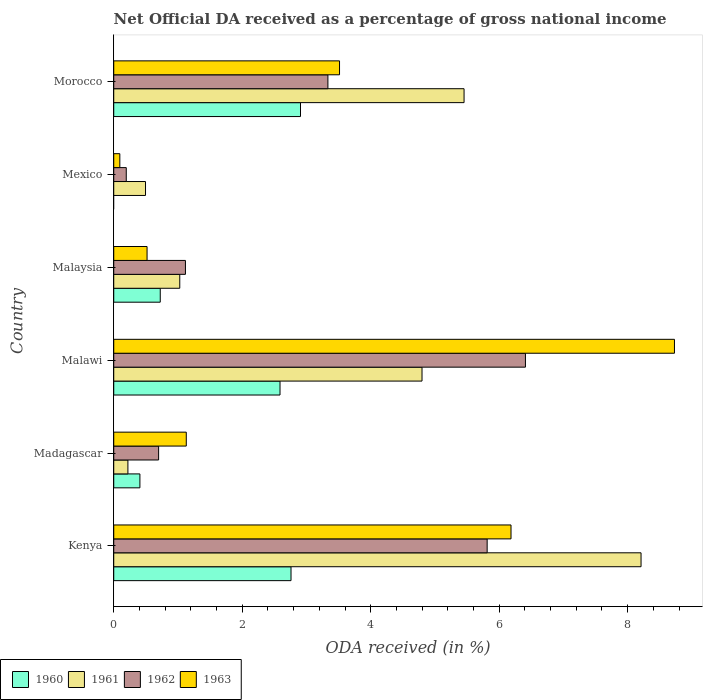How many groups of bars are there?
Keep it short and to the point. 6. Are the number of bars on each tick of the Y-axis equal?
Make the answer very short. No. How many bars are there on the 5th tick from the top?
Offer a very short reply. 4. How many bars are there on the 1st tick from the bottom?
Make the answer very short. 4. What is the label of the 6th group of bars from the top?
Offer a very short reply. Kenya. What is the net official DA received in 1961 in Morocco?
Your answer should be compact. 5.45. Across all countries, what is the maximum net official DA received in 1961?
Provide a succinct answer. 8.21. Across all countries, what is the minimum net official DA received in 1962?
Your answer should be very brief. 0.2. In which country was the net official DA received in 1963 maximum?
Provide a short and direct response. Malawi. What is the total net official DA received in 1963 in the graph?
Provide a short and direct response. 20.17. What is the difference between the net official DA received in 1962 in Malawi and that in Mexico?
Your answer should be very brief. 6.21. What is the difference between the net official DA received in 1961 in Morocco and the net official DA received in 1963 in Malaysia?
Give a very brief answer. 4.93. What is the average net official DA received in 1961 per country?
Your response must be concise. 3.37. What is the difference between the net official DA received in 1960 and net official DA received in 1963 in Malaysia?
Give a very brief answer. 0.21. What is the ratio of the net official DA received in 1963 in Madagascar to that in Mexico?
Your answer should be very brief. 11.92. Is the difference between the net official DA received in 1960 in Malawi and Malaysia greater than the difference between the net official DA received in 1963 in Malawi and Malaysia?
Make the answer very short. No. What is the difference between the highest and the second highest net official DA received in 1963?
Offer a very short reply. 2.54. What is the difference between the highest and the lowest net official DA received in 1962?
Offer a terse response. 6.21. Does the graph contain grids?
Provide a short and direct response. No. Where does the legend appear in the graph?
Your answer should be compact. Bottom left. What is the title of the graph?
Keep it short and to the point. Net Official DA received as a percentage of gross national income. Does "1966" appear as one of the legend labels in the graph?
Keep it short and to the point. No. What is the label or title of the X-axis?
Offer a very short reply. ODA received (in %). What is the ODA received (in %) in 1960 in Kenya?
Keep it short and to the point. 2.76. What is the ODA received (in %) of 1961 in Kenya?
Keep it short and to the point. 8.21. What is the ODA received (in %) in 1962 in Kenya?
Keep it short and to the point. 5.81. What is the ODA received (in %) in 1963 in Kenya?
Provide a succinct answer. 6.18. What is the ODA received (in %) of 1960 in Madagascar?
Your response must be concise. 0.41. What is the ODA received (in %) of 1961 in Madagascar?
Keep it short and to the point. 0.22. What is the ODA received (in %) of 1962 in Madagascar?
Your answer should be compact. 0.7. What is the ODA received (in %) of 1963 in Madagascar?
Offer a terse response. 1.13. What is the ODA received (in %) of 1960 in Malawi?
Make the answer very short. 2.59. What is the ODA received (in %) of 1961 in Malawi?
Provide a succinct answer. 4.8. What is the ODA received (in %) in 1962 in Malawi?
Keep it short and to the point. 6.41. What is the ODA received (in %) in 1963 in Malawi?
Keep it short and to the point. 8.73. What is the ODA received (in %) of 1960 in Malaysia?
Keep it short and to the point. 0.72. What is the ODA received (in %) of 1961 in Malaysia?
Your answer should be very brief. 1.03. What is the ODA received (in %) of 1962 in Malaysia?
Offer a terse response. 1.12. What is the ODA received (in %) of 1963 in Malaysia?
Offer a very short reply. 0.52. What is the ODA received (in %) in 1960 in Mexico?
Make the answer very short. 0. What is the ODA received (in %) of 1961 in Mexico?
Give a very brief answer. 0.49. What is the ODA received (in %) of 1962 in Mexico?
Your answer should be compact. 0.2. What is the ODA received (in %) in 1963 in Mexico?
Offer a very short reply. 0.09. What is the ODA received (in %) in 1960 in Morocco?
Your answer should be very brief. 2.91. What is the ODA received (in %) of 1961 in Morocco?
Your answer should be very brief. 5.45. What is the ODA received (in %) of 1962 in Morocco?
Your answer should be compact. 3.33. What is the ODA received (in %) in 1963 in Morocco?
Offer a very short reply. 3.51. Across all countries, what is the maximum ODA received (in %) in 1960?
Your answer should be very brief. 2.91. Across all countries, what is the maximum ODA received (in %) of 1961?
Offer a very short reply. 8.21. Across all countries, what is the maximum ODA received (in %) of 1962?
Offer a terse response. 6.41. Across all countries, what is the maximum ODA received (in %) of 1963?
Provide a succinct answer. 8.73. Across all countries, what is the minimum ODA received (in %) of 1961?
Provide a succinct answer. 0.22. Across all countries, what is the minimum ODA received (in %) of 1962?
Provide a succinct answer. 0.2. Across all countries, what is the minimum ODA received (in %) in 1963?
Ensure brevity in your answer.  0.09. What is the total ODA received (in %) in 1960 in the graph?
Ensure brevity in your answer.  9.39. What is the total ODA received (in %) in 1961 in the graph?
Ensure brevity in your answer.  20.2. What is the total ODA received (in %) of 1962 in the graph?
Your answer should be very brief. 17.56. What is the total ODA received (in %) of 1963 in the graph?
Your response must be concise. 20.17. What is the difference between the ODA received (in %) of 1960 in Kenya and that in Madagascar?
Make the answer very short. 2.35. What is the difference between the ODA received (in %) in 1961 in Kenya and that in Madagascar?
Provide a short and direct response. 7.99. What is the difference between the ODA received (in %) of 1962 in Kenya and that in Madagascar?
Keep it short and to the point. 5.11. What is the difference between the ODA received (in %) of 1963 in Kenya and that in Madagascar?
Keep it short and to the point. 5.06. What is the difference between the ODA received (in %) in 1960 in Kenya and that in Malawi?
Provide a succinct answer. 0.17. What is the difference between the ODA received (in %) in 1961 in Kenya and that in Malawi?
Give a very brief answer. 3.41. What is the difference between the ODA received (in %) of 1962 in Kenya and that in Malawi?
Provide a succinct answer. -0.6. What is the difference between the ODA received (in %) in 1963 in Kenya and that in Malawi?
Give a very brief answer. -2.54. What is the difference between the ODA received (in %) in 1960 in Kenya and that in Malaysia?
Offer a very short reply. 2.04. What is the difference between the ODA received (in %) in 1961 in Kenya and that in Malaysia?
Provide a short and direct response. 7.18. What is the difference between the ODA received (in %) in 1962 in Kenya and that in Malaysia?
Provide a succinct answer. 4.7. What is the difference between the ODA received (in %) of 1963 in Kenya and that in Malaysia?
Your answer should be compact. 5.67. What is the difference between the ODA received (in %) in 1961 in Kenya and that in Mexico?
Provide a succinct answer. 7.71. What is the difference between the ODA received (in %) in 1962 in Kenya and that in Mexico?
Your answer should be compact. 5.62. What is the difference between the ODA received (in %) in 1963 in Kenya and that in Mexico?
Your answer should be compact. 6.09. What is the difference between the ODA received (in %) of 1960 in Kenya and that in Morocco?
Your answer should be very brief. -0.15. What is the difference between the ODA received (in %) in 1961 in Kenya and that in Morocco?
Provide a short and direct response. 2.76. What is the difference between the ODA received (in %) of 1962 in Kenya and that in Morocco?
Offer a terse response. 2.48. What is the difference between the ODA received (in %) of 1963 in Kenya and that in Morocco?
Offer a very short reply. 2.67. What is the difference between the ODA received (in %) in 1960 in Madagascar and that in Malawi?
Ensure brevity in your answer.  -2.18. What is the difference between the ODA received (in %) of 1961 in Madagascar and that in Malawi?
Your answer should be very brief. -4.58. What is the difference between the ODA received (in %) of 1962 in Madagascar and that in Malawi?
Provide a succinct answer. -5.71. What is the difference between the ODA received (in %) of 1963 in Madagascar and that in Malawi?
Make the answer very short. -7.6. What is the difference between the ODA received (in %) of 1960 in Madagascar and that in Malaysia?
Offer a terse response. -0.32. What is the difference between the ODA received (in %) in 1961 in Madagascar and that in Malaysia?
Offer a very short reply. -0.81. What is the difference between the ODA received (in %) of 1962 in Madagascar and that in Malaysia?
Ensure brevity in your answer.  -0.42. What is the difference between the ODA received (in %) of 1963 in Madagascar and that in Malaysia?
Keep it short and to the point. 0.61. What is the difference between the ODA received (in %) of 1961 in Madagascar and that in Mexico?
Give a very brief answer. -0.27. What is the difference between the ODA received (in %) in 1962 in Madagascar and that in Mexico?
Make the answer very short. 0.5. What is the difference between the ODA received (in %) of 1963 in Madagascar and that in Mexico?
Your response must be concise. 1.03. What is the difference between the ODA received (in %) of 1960 in Madagascar and that in Morocco?
Provide a short and direct response. -2.5. What is the difference between the ODA received (in %) of 1961 in Madagascar and that in Morocco?
Your answer should be compact. -5.23. What is the difference between the ODA received (in %) of 1962 in Madagascar and that in Morocco?
Provide a short and direct response. -2.64. What is the difference between the ODA received (in %) of 1963 in Madagascar and that in Morocco?
Give a very brief answer. -2.39. What is the difference between the ODA received (in %) of 1960 in Malawi and that in Malaysia?
Your response must be concise. 1.86. What is the difference between the ODA received (in %) in 1961 in Malawi and that in Malaysia?
Your answer should be compact. 3.77. What is the difference between the ODA received (in %) in 1962 in Malawi and that in Malaysia?
Make the answer very short. 5.29. What is the difference between the ODA received (in %) of 1963 in Malawi and that in Malaysia?
Your response must be concise. 8.21. What is the difference between the ODA received (in %) in 1961 in Malawi and that in Mexico?
Make the answer very short. 4.3. What is the difference between the ODA received (in %) of 1962 in Malawi and that in Mexico?
Keep it short and to the point. 6.21. What is the difference between the ODA received (in %) of 1963 in Malawi and that in Mexico?
Provide a short and direct response. 8.63. What is the difference between the ODA received (in %) in 1960 in Malawi and that in Morocco?
Offer a very short reply. -0.32. What is the difference between the ODA received (in %) in 1961 in Malawi and that in Morocco?
Your response must be concise. -0.65. What is the difference between the ODA received (in %) in 1962 in Malawi and that in Morocco?
Provide a succinct answer. 3.08. What is the difference between the ODA received (in %) in 1963 in Malawi and that in Morocco?
Ensure brevity in your answer.  5.21. What is the difference between the ODA received (in %) of 1961 in Malaysia and that in Mexico?
Offer a terse response. 0.53. What is the difference between the ODA received (in %) of 1962 in Malaysia and that in Mexico?
Ensure brevity in your answer.  0.92. What is the difference between the ODA received (in %) of 1963 in Malaysia and that in Mexico?
Provide a succinct answer. 0.42. What is the difference between the ODA received (in %) in 1960 in Malaysia and that in Morocco?
Provide a succinct answer. -2.18. What is the difference between the ODA received (in %) of 1961 in Malaysia and that in Morocco?
Offer a terse response. -4.43. What is the difference between the ODA received (in %) in 1962 in Malaysia and that in Morocco?
Offer a terse response. -2.22. What is the difference between the ODA received (in %) of 1963 in Malaysia and that in Morocco?
Ensure brevity in your answer.  -3. What is the difference between the ODA received (in %) in 1961 in Mexico and that in Morocco?
Keep it short and to the point. -4.96. What is the difference between the ODA received (in %) of 1962 in Mexico and that in Morocco?
Make the answer very short. -3.14. What is the difference between the ODA received (in %) in 1963 in Mexico and that in Morocco?
Keep it short and to the point. -3.42. What is the difference between the ODA received (in %) of 1960 in Kenya and the ODA received (in %) of 1961 in Madagascar?
Provide a short and direct response. 2.54. What is the difference between the ODA received (in %) in 1960 in Kenya and the ODA received (in %) in 1962 in Madagascar?
Make the answer very short. 2.06. What is the difference between the ODA received (in %) of 1960 in Kenya and the ODA received (in %) of 1963 in Madagascar?
Ensure brevity in your answer.  1.63. What is the difference between the ODA received (in %) of 1961 in Kenya and the ODA received (in %) of 1962 in Madagascar?
Ensure brevity in your answer.  7.51. What is the difference between the ODA received (in %) in 1961 in Kenya and the ODA received (in %) in 1963 in Madagascar?
Your response must be concise. 7.08. What is the difference between the ODA received (in %) of 1962 in Kenya and the ODA received (in %) of 1963 in Madagascar?
Offer a very short reply. 4.68. What is the difference between the ODA received (in %) of 1960 in Kenya and the ODA received (in %) of 1961 in Malawi?
Provide a succinct answer. -2.04. What is the difference between the ODA received (in %) of 1960 in Kenya and the ODA received (in %) of 1962 in Malawi?
Ensure brevity in your answer.  -3.65. What is the difference between the ODA received (in %) of 1960 in Kenya and the ODA received (in %) of 1963 in Malawi?
Offer a terse response. -5.97. What is the difference between the ODA received (in %) of 1961 in Kenya and the ODA received (in %) of 1962 in Malawi?
Keep it short and to the point. 1.8. What is the difference between the ODA received (in %) of 1961 in Kenya and the ODA received (in %) of 1963 in Malawi?
Provide a succinct answer. -0.52. What is the difference between the ODA received (in %) in 1962 in Kenya and the ODA received (in %) in 1963 in Malawi?
Make the answer very short. -2.92. What is the difference between the ODA received (in %) in 1960 in Kenya and the ODA received (in %) in 1961 in Malaysia?
Ensure brevity in your answer.  1.73. What is the difference between the ODA received (in %) of 1960 in Kenya and the ODA received (in %) of 1962 in Malaysia?
Ensure brevity in your answer.  1.64. What is the difference between the ODA received (in %) in 1960 in Kenya and the ODA received (in %) in 1963 in Malaysia?
Give a very brief answer. 2.24. What is the difference between the ODA received (in %) of 1961 in Kenya and the ODA received (in %) of 1962 in Malaysia?
Provide a short and direct response. 7.09. What is the difference between the ODA received (in %) in 1961 in Kenya and the ODA received (in %) in 1963 in Malaysia?
Keep it short and to the point. 7.69. What is the difference between the ODA received (in %) of 1962 in Kenya and the ODA received (in %) of 1963 in Malaysia?
Your response must be concise. 5.29. What is the difference between the ODA received (in %) of 1960 in Kenya and the ODA received (in %) of 1961 in Mexico?
Your answer should be very brief. 2.26. What is the difference between the ODA received (in %) in 1960 in Kenya and the ODA received (in %) in 1962 in Mexico?
Ensure brevity in your answer.  2.56. What is the difference between the ODA received (in %) of 1960 in Kenya and the ODA received (in %) of 1963 in Mexico?
Provide a succinct answer. 2.66. What is the difference between the ODA received (in %) of 1961 in Kenya and the ODA received (in %) of 1962 in Mexico?
Your answer should be very brief. 8.01. What is the difference between the ODA received (in %) in 1961 in Kenya and the ODA received (in %) in 1963 in Mexico?
Give a very brief answer. 8.11. What is the difference between the ODA received (in %) in 1962 in Kenya and the ODA received (in %) in 1963 in Mexico?
Your answer should be compact. 5.72. What is the difference between the ODA received (in %) of 1960 in Kenya and the ODA received (in %) of 1961 in Morocco?
Your answer should be compact. -2.69. What is the difference between the ODA received (in %) of 1960 in Kenya and the ODA received (in %) of 1962 in Morocco?
Your answer should be compact. -0.57. What is the difference between the ODA received (in %) in 1960 in Kenya and the ODA received (in %) in 1963 in Morocco?
Make the answer very short. -0.76. What is the difference between the ODA received (in %) in 1961 in Kenya and the ODA received (in %) in 1962 in Morocco?
Offer a terse response. 4.87. What is the difference between the ODA received (in %) in 1961 in Kenya and the ODA received (in %) in 1963 in Morocco?
Ensure brevity in your answer.  4.69. What is the difference between the ODA received (in %) of 1962 in Kenya and the ODA received (in %) of 1963 in Morocco?
Offer a terse response. 2.3. What is the difference between the ODA received (in %) in 1960 in Madagascar and the ODA received (in %) in 1961 in Malawi?
Make the answer very short. -4.39. What is the difference between the ODA received (in %) of 1960 in Madagascar and the ODA received (in %) of 1962 in Malawi?
Keep it short and to the point. -6. What is the difference between the ODA received (in %) of 1960 in Madagascar and the ODA received (in %) of 1963 in Malawi?
Make the answer very short. -8.32. What is the difference between the ODA received (in %) of 1961 in Madagascar and the ODA received (in %) of 1962 in Malawi?
Offer a very short reply. -6.19. What is the difference between the ODA received (in %) of 1961 in Madagascar and the ODA received (in %) of 1963 in Malawi?
Ensure brevity in your answer.  -8.51. What is the difference between the ODA received (in %) in 1962 in Madagascar and the ODA received (in %) in 1963 in Malawi?
Make the answer very short. -8.03. What is the difference between the ODA received (in %) in 1960 in Madagascar and the ODA received (in %) in 1961 in Malaysia?
Offer a terse response. -0.62. What is the difference between the ODA received (in %) of 1960 in Madagascar and the ODA received (in %) of 1962 in Malaysia?
Provide a short and direct response. -0.71. What is the difference between the ODA received (in %) of 1960 in Madagascar and the ODA received (in %) of 1963 in Malaysia?
Your answer should be compact. -0.11. What is the difference between the ODA received (in %) in 1961 in Madagascar and the ODA received (in %) in 1962 in Malaysia?
Provide a short and direct response. -0.9. What is the difference between the ODA received (in %) in 1961 in Madagascar and the ODA received (in %) in 1963 in Malaysia?
Offer a very short reply. -0.3. What is the difference between the ODA received (in %) in 1962 in Madagascar and the ODA received (in %) in 1963 in Malaysia?
Your answer should be very brief. 0.18. What is the difference between the ODA received (in %) in 1960 in Madagascar and the ODA received (in %) in 1961 in Mexico?
Your response must be concise. -0.09. What is the difference between the ODA received (in %) of 1960 in Madagascar and the ODA received (in %) of 1962 in Mexico?
Give a very brief answer. 0.21. What is the difference between the ODA received (in %) of 1960 in Madagascar and the ODA received (in %) of 1963 in Mexico?
Offer a very short reply. 0.31. What is the difference between the ODA received (in %) in 1961 in Madagascar and the ODA received (in %) in 1962 in Mexico?
Offer a terse response. 0.03. What is the difference between the ODA received (in %) of 1961 in Madagascar and the ODA received (in %) of 1963 in Mexico?
Ensure brevity in your answer.  0.13. What is the difference between the ODA received (in %) in 1962 in Madagascar and the ODA received (in %) in 1963 in Mexico?
Offer a terse response. 0.6. What is the difference between the ODA received (in %) in 1960 in Madagascar and the ODA received (in %) in 1961 in Morocco?
Make the answer very short. -5.05. What is the difference between the ODA received (in %) in 1960 in Madagascar and the ODA received (in %) in 1962 in Morocco?
Your answer should be very brief. -2.93. What is the difference between the ODA received (in %) in 1960 in Madagascar and the ODA received (in %) in 1963 in Morocco?
Make the answer very short. -3.11. What is the difference between the ODA received (in %) of 1961 in Madagascar and the ODA received (in %) of 1962 in Morocco?
Give a very brief answer. -3.11. What is the difference between the ODA received (in %) in 1961 in Madagascar and the ODA received (in %) in 1963 in Morocco?
Your response must be concise. -3.29. What is the difference between the ODA received (in %) in 1962 in Madagascar and the ODA received (in %) in 1963 in Morocco?
Give a very brief answer. -2.82. What is the difference between the ODA received (in %) in 1960 in Malawi and the ODA received (in %) in 1961 in Malaysia?
Your response must be concise. 1.56. What is the difference between the ODA received (in %) in 1960 in Malawi and the ODA received (in %) in 1962 in Malaysia?
Offer a terse response. 1.47. What is the difference between the ODA received (in %) in 1960 in Malawi and the ODA received (in %) in 1963 in Malaysia?
Your answer should be very brief. 2.07. What is the difference between the ODA received (in %) in 1961 in Malawi and the ODA received (in %) in 1962 in Malaysia?
Your answer should be compact. 3.68. What is the difference between the ODA received (in %) in 1961 in Malawi and the ODA received (in %) in 1963 in Malaysia?
Provide a short and direct response. 4.28. What is the difference between the ODA received (in %) of 1962 in Malawi and the ODA received (in %) of 1963 in Malaysia?
Keep it short and to the point. 5.89. What is the difference between the ODA received (in %) of 1960 in Malawi and the ODA received (in %) of 1961 in Mexico?
Provide a succinct answer. 2.09. What is the difference between the ODA received (in %) in 1960 in Malawi and the ODA received (in %) in 1962 in Mexico?
Provide a succinct answer. 2.39. What is the difference between the ODA received (in %) of 1960 in Malawi and the ODA received (in %) of 1963 in Mexico?
Offer a terse response. 2.49. What is the difference between the ODA received (in %) of 1961 in Malawi and the ODA received (in %) of 1962 in Mexico?
Provide a succinct answer. 4.6. What is the difference between the ODA received (in %) in 1961 in Malawi and the ODA received (in %) in 1963 in Mexico?
Make the answer very short. 4.7. What is the difference between the ODA received (in %) of 1962 in Malawi and the ODA received (in %) of 1963 in Mexico?
Give a very brief answer. 6.31. What is the difference between the ODA received (in %) of 1960 in Malawi and the ODA received (in %) of 1961 in Morocco?
Your response must be concise. -2.87. What is the difference between the ODA received (in %) of 1960 in Malawi and the ODA received (in %) of 1962 in Morocco?
Offer a very short reply. -0.75. What is the difference between the ODA received (in %) in 1960 in Malawi and the ODA received (in %) in 1963 in Morocco?
Your answer should be very brief. -0.93. What is the difference between the ODA received (in %) of 1961 in Malawi and the ODA received (in %) of 1962 in Morocco?
Offer a terse response. 1.47. What is the difference between the ODA received (in %) of 1961 in Malawi and the ODA received (in %) of 1963 in Morocco?
Your answer should be compact. 1.28. What is the difference between the ODA received (in %) of 1962 in Malawi and the ODA received (in %) of 1963 in Morocco?
Make the answer very short. 2.89. What is the difference between the ODA received (in %) of 1960 in Malaysia and the ODA received (in %) of 1961 in Mexico?
Offer a very short reply. 0.23. What is the difference between the ODA received (in %) of 1960 in Malaysia and the ODA received (in %) of 1962 in Mexico?
Give a very brief answer. 0.53. What is the difference between the ODA received (in %) of 1960 in Malaysia and the ODA received (in %) of 1963 in Mexico?
Keep it short and to the point. 0.63. What is the difference between the ODA received (in %) of 1961 in Malaysia and the ODA received (in %) of 1962 in Mexico?
Provide a succinct answer. 0.83. What is the difference between the ODA received (in %) of 1961 in Malaysia and the ODA received (in %) of 1963 in Mexico?
Provide a succinct answer. 0.93. What is the difference between the ODA received (in %) in 1962 in Malaysia and the ODA received (in %) in 1963 in Mexico?
Provide a succinct answer. 1.02. What is the difference between the ODA received (in %) in 1960 in Malaysia and the ODA received (in %) in 1961 in Morocco?
Give a very brief answer. -4.73. What is the difference between the ODA received (in %) of 1960 in Malaysia and the ODA received (in %) of 1962 in Morocco?
Your answer should be compact. -2.61. What is the difference between the ODA received (in %) in 1960 in Malaysia and the ODA received (in %) in 1963 in Morocco?
Offer a very short reply. -2.79. What is the difference between the ODA received (in %) of 1961 in Malaysia and the ODA received (in %) of 1962 in Morocco?
Give a very brief answer. -2.31. What is the difference between the ODA received (in %) in 1961 in Malaysia and the ODA received (in %) in 1963 in Morocco?
Offer a very short reply. -2.49. What is the difference between the ODA received (in %) of 1962 in Malaysia and the ODA received (in %) of 1963 in Morocco?
Offer a very short reply. -2.4. What is the difference between the ODA received (in %) of 1961 in Mexico and the ODA received (in %) of 1962 in Morocco?
Offer a terse response. -2.84. What is the difference between the ODA received (in %) of 1961 in Mexico and the ODA received (in %) of 1963 in Morocco?
Make the answer very short. -3.02. What is the difference between the ODA received (in %) of 1962 in Mexico and the ODA received (in %) of 1963 in Morocco?
Offer a very short reply. -3.32. What is the average ODA received (in %) in 1960 per country?
Keep it short and to the point. 1.56. What is the average ODA received (in %) in 1961 per country?
Your response must be concise. 3.37. What is the average ODA received (in %) of 1962 per country?
Provide a short and direct response. 2.93. What is the average ODA received (in %) of 1963 per country?
Your answer should be compact. 3.36. What is the difference between the ODA received (in %) in 1960 and ODA received (in %) in 1961 in Kenya?
Offer a very short reply. -5.45. What is the difference between the ODA received (in %) in 1960 and ODA received (in %) in 1962 in Kenya?
Give a very brief answer. -3.05. What is the difference between the ODA received (in %) in 1960 and ODA received (in %) in 1963 in Kenya?
Offer a terse response. -3.42. What is the difference between the ODA received (in %) of 1961 and ODA received (in %) of 1962 in Kenya?
Give a very brief answer. 2.4. What is the difference between the ODA received (in %) of 1961 and ODA received (in %) of 1963 in Kenya?
Give a very brief answer. 2.02. What is the difference between the ODA received (in %) in 1962 and ODA received (in %) in 1963 in Kenya?
Keep it short and to the point. -0.37. What is the difference between the ODA received (in %) in 1960 and ODA received (in %) in 1961 in Madagascar?
Offer a very short reply. 0.19. What is the difference between the ODA received (in %) in 1960 and ODA received (in %) in 1962 in Madagascar?
Your answer should be compact. -0.29. What is the difference between the ODA received (in %) in 1960 and ODA received (in %) in 1963 in Madagascar?
Your answer should be compact. -0.72. What is the difference between the ODA received (in %) of 1961 and ODA received (in %) of 1962 in Madagascar?
Your answer should be compact. -0.48. What is the difference between the ODA received (in %) in 1961 and ODA received (in %) in 1963 in Madagascar?
Make the answer very short. -0.91. What is the difference between the ODA received (in %) of 1962 and ODA received (in %) of 1963 in Madagascar?
Your answer should be very brief. -0.43. What is the difference between the ODA received (in %) in 1960 and ODA received (in %) in 1961 in Malawi?
Your answer should be very brief. -2.21. What is the difference between the ODA received (in %) in 1960 and ODA received (in %) in 1962 in Malawi?
Your response must be concise. -3.82. What is the difference between the ODA received (in %) in 1960 and ODA received (in %) in 1963 in Malawi?
Ensure brevity in your answer.  -6.14. What is the difference between the ODA received (in %) in 1961 and ODA received (in %) in 1962 in Malawi?
Your answer should be very brief. -1.61. What is the difference between the ODA received (in %) of 1961 and ODA received (in %) of 1963 in Malawi?
Provide a succinct answer. -3.93. What is the difference between the ODA received (in %) of 1962 and ODA received (in %) of 1963 in Malawi?
Give a very brief answer. -2.32. What is the difference between the ODA received (in %) of 1960 and ODA received (in %) of 1961 in Malaysia?
Make the answer very short. -0.3. What is the difference between the ODA received (in %) in 1960 and ODA received (in %) in 1962 in Malaysia?
Your answer should be very brief. -0.39. What is the difference between the ODA received (in %) in 1960 and ODA received (in %) in 1963 in Malaysia?
Your answer should be compact. 0.21. What is the difference between the ODA received (in %) of 1961 and ODA received (in %) of 1962 in Malaysia?
Provide a short and direct response. -0.09. What is the difference between the ODA received (in %) of 1961 and ODA received (in %) of 1963 in Malaysia?
Offer a terse response. 0.51. What is the difference between the ODA received (in %) in 1962 and ODA received (in %) in 1963 in Malaysia?
Ensure brevity in your answer.  0.6. What is the difference between the ODA received (in %) in 1961 and ODA received (in %) in 1962 in Mexico?
Provide a succinct answer. 0.3. What is the difference between the ODA received (in %) of 1962 and ODA received (in %) of 1963 in Mexico?
Your response must be concise. 0.1. What is the difference between the ODA received (in %) of 1960 and ODA received (in %) of 1961 in Morocco?
Provide a succinct answer. -2.55. What is the difference between the ODA received (in %) of 1960 and ODA received (in %) of 1962 in Morocco?
Your response must be concise. -0.43. What is the difference between the ODA received (in %) in 1960 and ODA received (in %) in 1963 in Morocco?
Your answer should be very brief. -0.61. What is the difference between the ODA received (in %) in 1961 and ODA received (in %) in 1962 in Morocco?
Make the answer very short. 2.12. What is the difference between the ODA received (in %) in 1961 and ODA received (in %) in 1963 in Morocco?
Your response must be concise. 1.94. What is the difference between the ODA received (in %) of 1962 and ODA received (in %) of 1963 in Morocco?
Ensure brevity in your answer.  -0.18. What is the ratio of the ODA received (in %) of 1960 in Kenya to that in Madagascar?
Your answer should be compact. 6.78. What is the ratio of the ODA received (in %) of 1961 in Kenya to that in Madagascar?
Your answer should be very brief. 37.24. What is the ratio of the ODA received (in %) of 1962 in Kenya to that in Madagascar?
Keep it short and to the point. 8.32. What is the ratio of the ODA received (in %) of 1963 in Kenya to that in Madagascar?
Give a very brief answer. 5.48. What is the ratio of the ODA received (in %) in 1960 in Kenya to that in Malawi?
Make the answer very short. 1.07. What is the ratio of the ODA received (in %) of 1961 in Kenya to that in Malawi?
Your answer should be very brief. 1.71. What is the ratio of the ODA received (in %) in 1962 in Kenya to that in Malawi?
Ensure brevity in your answer.  0.91. What is the ratio of the ODA received (in %) of 1963 in Kenya to that in Malawi?
Ensure brevity in your answer.  0.71. What is the ratio of the ODA received (in %) in 1960 in Kenya to that in Malaysia?
Keep it short and to the point. 3.81. What is the ratio of the ODA received (in %) of 1961 in Kenya to that in Malaysia?
Provide a short and direct response. 7.99. What is the ratio of the ODA received (in %) of 1962 in Kenya to that in Malaysia?
Offer a very short reply. 5.21. What is the ratio of the ODA received (in %) in 1963 in Kenya to that in Malaysia?
Offer a terse response. 11.92. What is the ratio of the ODA received (in %) in 1961 in Kenya to that in Mexico?
Your answer should be very brief. 16.59. What is the ratio of the ODA received (in %) of 1962 in Kenya to that in Mexico?
Make the answer very short. 29.8. What is the ratio of the ODA received (in %) in 1963 in Kenya to that in Mexico?
Offer a terse response. 65.31. What is the ratio of the ODA received (in %) in 1960 in Kenya to that in Morocco?
Provide a succinct answer. 0.95. What is the ratio of the ODA received (in %) of 1961 in Kenya to that in Morocco?
Offer a terse response. 1.51. What is the ratio of the ODA received (in %) in 1962 in Kenya to that in Morocco?
Your answer should be compact. 1.74. What is the ratio of the ODA received (in %) in 1963 in Kenya to that in Morocco?
Provide a succinct answer. 1.76. What is the ratio of the ODA received (in %) of 1960 in Madagascar to that in Malawi?
Offer a terse response. 0.16. What is the ratio of the ODA received (in %) in 1961 in Madagascar to that in Malawi?
Your answer should be very brief. 0.05. What is the ratio of the ODA received (in %) of 1962 in Madagascar to that in Malawi?
Provide a succinct answer. 0.11. What is the ratio of the ODA received (in %) of 1963 in Madagascar to that in Malawi?
Your answer should be compact. 0.13. What is the ratio of the ODA received (in %) in 1960 in Madagascar to that in Malaysia?
Give a very brief answer. 0.56. What is the ratio of the ODA received (in %) of 1961 in Madagascar to that in Malaysia?
Make the answer very short. 0.21. What is the ratio of the ODA received (in %) in 1962 in Madagascar to that in Malaysia?
Give a very brief answer. 0.63. What is the ratio of the ODA received (in %) in 1963 in Madagascar to that in Malaysia?
Give a very brief answer. 2.18. What is the ratio of the ODA received (in %) of 1961 in Madagascar to that in Mexico?
Offer a very short reply. 0.45. What is the ratio of the ODA received (in %) in 1962 in Madagascar to that in Mexico?
Your answer should be compact. 3.58. What is the ratio of the ODA received (in %) of 1963 in Madagascar to that in Mexico?
Provide a succinct answer. 11.92. What is the ratio of the ODA received (in %) of 1960 in Madagascar to that in Morocco?
Offer a very short reply. 0.14. What is the ratio of the ODA received (in %) of 1961 in Madagascar to that in Morocco?
Ensure brevity in your answer.  0.04. What is the ratio of the ODA received (in %) of 1962 in Madagascar to that in Morocco?
Make the answer very short. 0.21. What is the ratio of the ODA received (in %) of 1963 in Madagascar to that in Morocco?
Make the answer very short. 0.32. What is the ratio of the ODA received (in %) of 1960 in Malawi to that in Malaysia?
Give a very brief answer. 3.58. What is the ratio of the ODA received (in %) in 1961 in Malawi to that in Malaysia?
Keep it short and to the point. 4.67. What is the ratio of the ODA received (in %) of 1962 in Malawi to that in Malaysia?
Offer a terse response. 5.74. What is the ratio of the ODA received (in %) of 1963 in Malawi to that in Malaysia?
Make the answer very short. 16.83. What is the ratio of the ODA received (in %) of 1962 in Malawi to that in Mexico?
Your answer should be very brief. 32.85. What is the ratio of the ODA received (in %) of 1963 in Malawi to that in Mexico?
Offer a terse response. 92.18. What is the ratio of the ODA received (in %) of 1960 in Malawi to that in Morocco?
Your response must be concise. 0.89. What is the ratio of the ODA received (in %) of 1961 in Malawi to that in Morocco?
Make the answer very short. 0.88. What is the ratio of the ODA received (in %) in 1962 in Malawi to that in Morocco?
Your response must be concise. 1.92. What is the ratio of the ODA received (in %) in 1963 in Malawi to that in Morocco?
Your answer should be compact. 2.48. What is the ratio of the ODA received (in %) in 1961 in Malaysia to that in Mexico?
Offer a very short reply. 2.08. What is the ratio of the ODA received (in %) in 1962 in Malaysia to that in Mexico?
Your answer should be compact. 5.72. What is the ratio of the ODA received (in %) in 1963 in Malaysia to that in Mexico?
Your answer should be compact. 5.48. What is the ratio of the ODA received (in %) in 1960 in Malaysia to that in Morocco?
Your answer should be compact. 0.25. What is the ratio of the ODA received (in %) of 1961 in Malaysia to that in Morocco?
Keep it short and to the point. 0.19. What is the ratio of the ODA received (in %) in 1962 in Malaysia to that in Morocco?
Your response must be concise. 0.33. What is the ratio of the ODA received (in %) of 1963 in Malaysia to that in Morocco?
Give a very brief answer. 0.15. What is the ratio of the ODA received (in %) in 1961 in Mexico to that in Morocco?
Make the answer very short. 0.09. What is the ratio of the ODA received (in %) in 1962 in Mexico to that in Morocco?
Offer a terse response. 0.06. What is the ratio of the ODA received (in %) in 1963 in Mexico to that in Morocco?
Give a very brief answer. 0.03. What is the difference between the highest and the second highest ODA received (in %) of 1960?
Offer a very short reply. 0.15. What is the difference between the highest and the second highest ODA received (in %) in 1961?
Your response must be concise. 2.76. What is the difference between the highest and the second highest ODA received (in %) of 1962?
Provide a short and direct response. 0.6. What is the difference between the highest and the second highest ODA received (in %) in 1963?
Provide a short and direct response. 2.54. What is the difference between the highest and the lowest ODA received (in %) in 1960?
Your answer should be very brief. 2.91. What is the difference between the highest and the lowest ODA received (in %) in 1961?
Give a very brief answer. 7.99. What is the difference between the highest and the lowest ODA received (in %) of 1962?
Ensure brevity in your answer.  6.21. What is the difference between the highest and the lowest ODA received (in %) in 1963?
Make the answer very short. 8.63. 